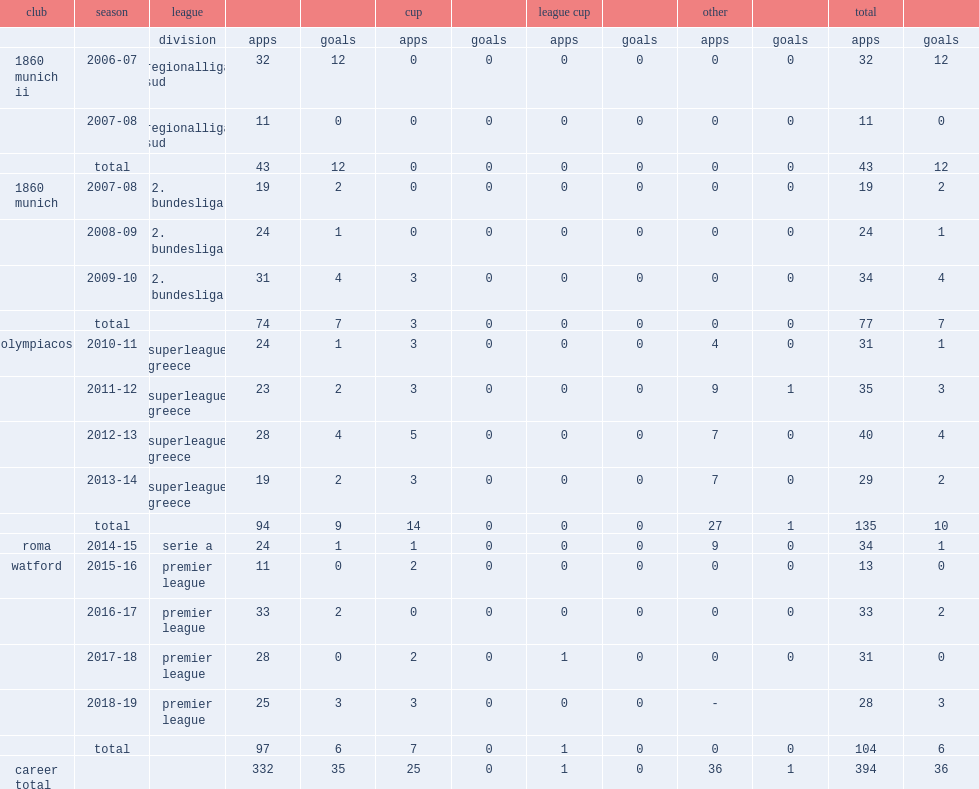Which club did jose holebas play for in 2015-16? Watford. 